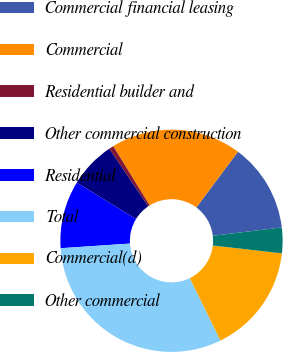Convert chart to OTSL. <chart><loc_0><loc_0><loc_500><loc_500><pie_chart><fcel>Commercial financial leasing<fcel>Commercial<fcel>Residential builder and<fcel>Other commercial construction<fcel>Residential<fcel>Total<fcel>Commercial(d)<fcel>Other commercial<nl><fcel>12.88%<fcel>18.99%<fcel>0.67%<fcel>6.78%<fcel>9.83%<fcel>31.2%<fcel>15.93%<fcel>3.72%<nl></chart> 